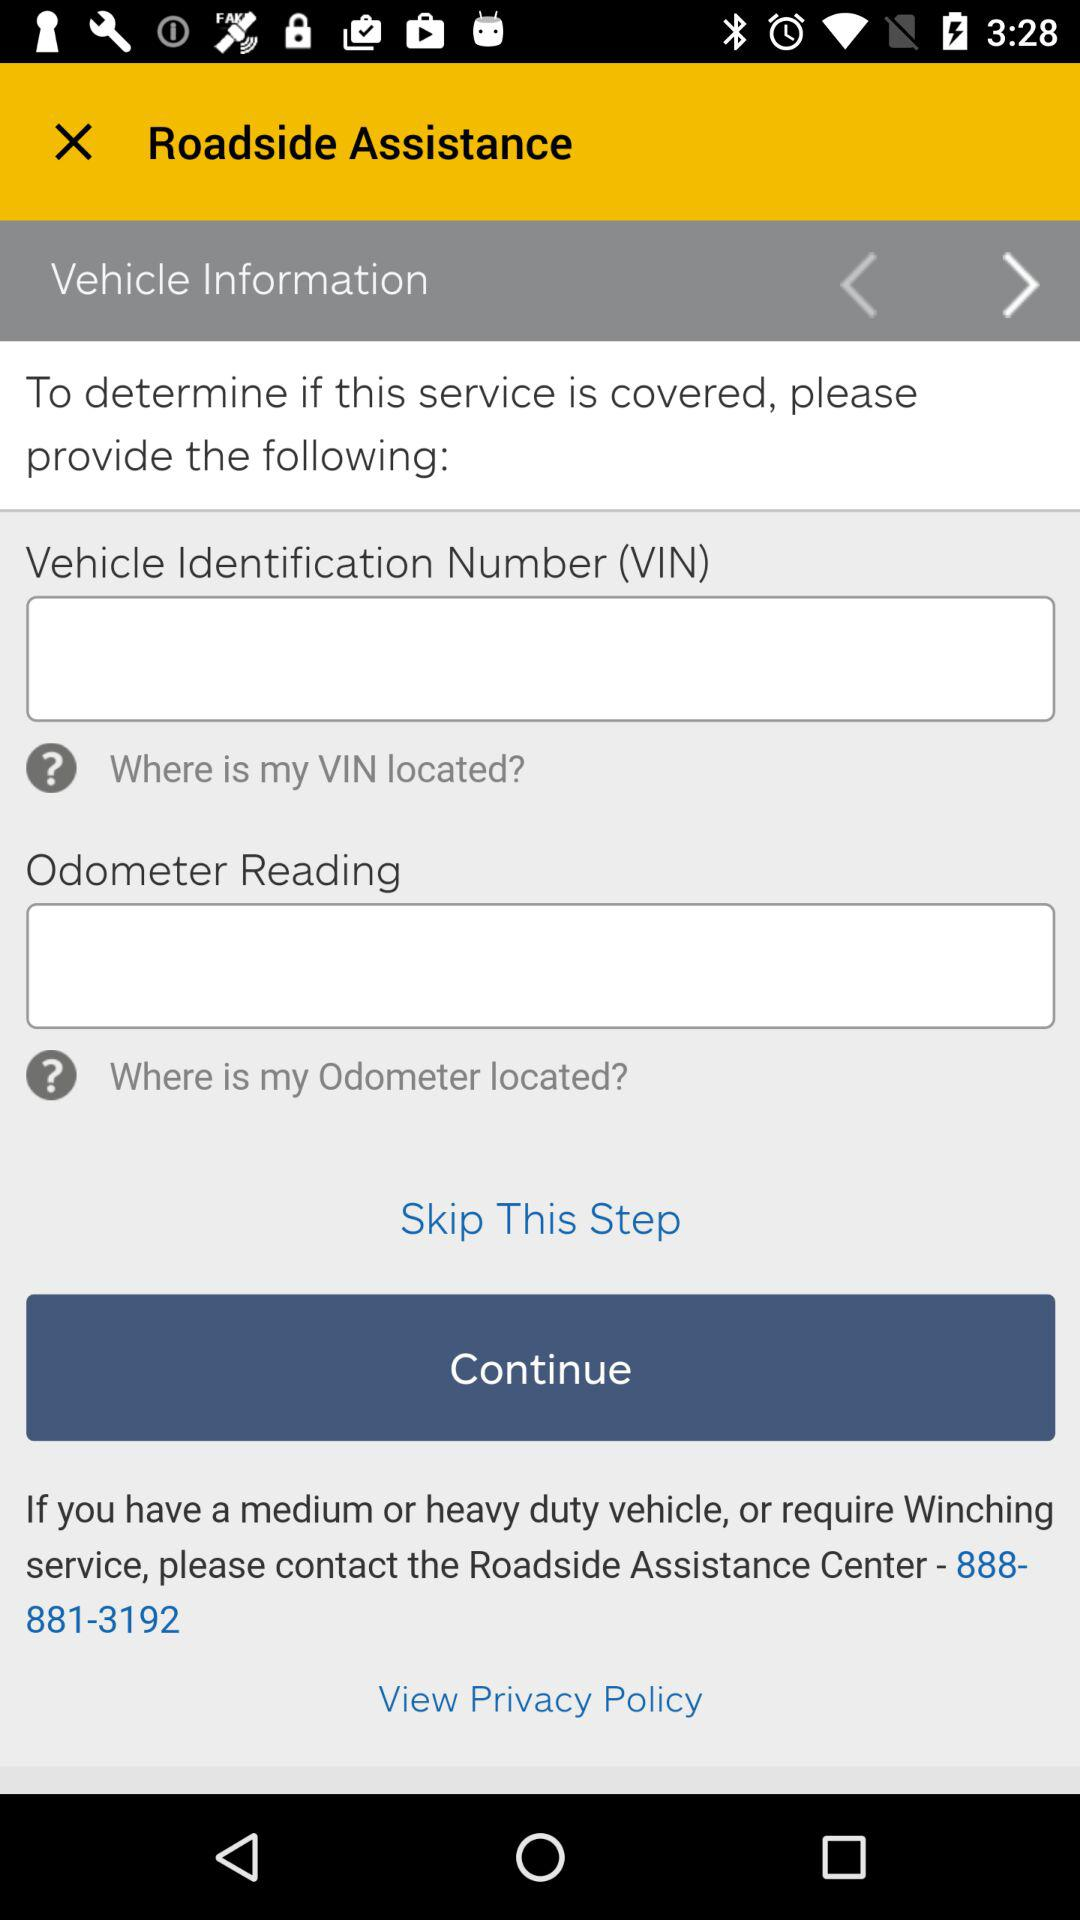What is the application name?
When the provided information is insufficient, respond with <no answer>. <no answer> 